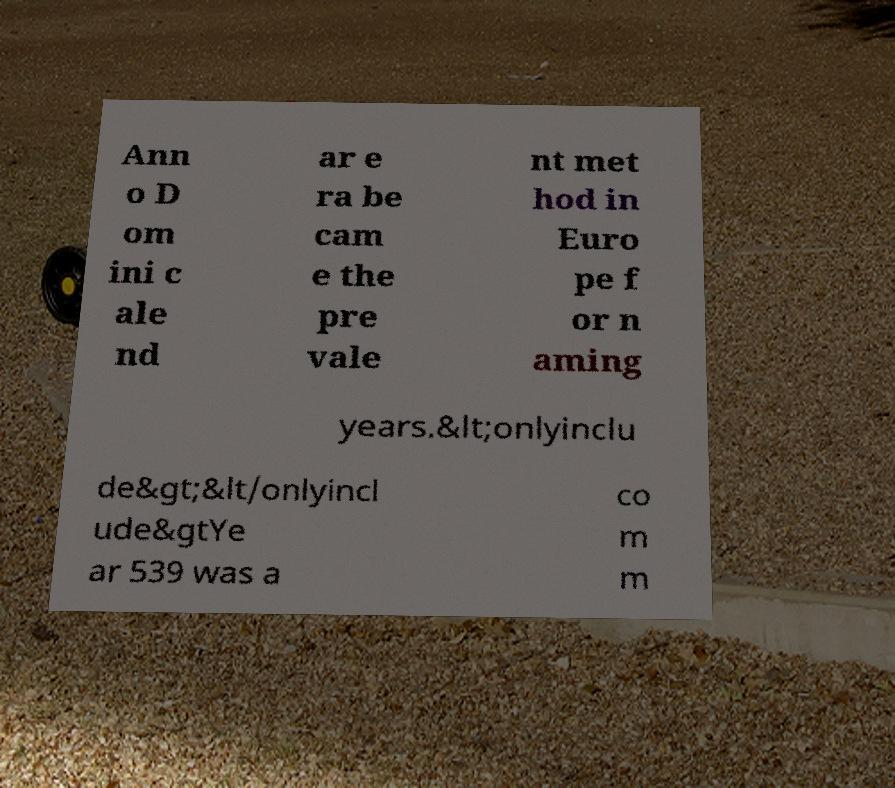Can you accurately transcribe the text from the provided image for me? Ann o D om ini c ale nd ar e ra be cam e the pre vale nt met hod in Euro pe f or n aming years.&lt;onlyinclu de&gt;&lt/onlyincl ude&gtYe ar 539 was a co m m 